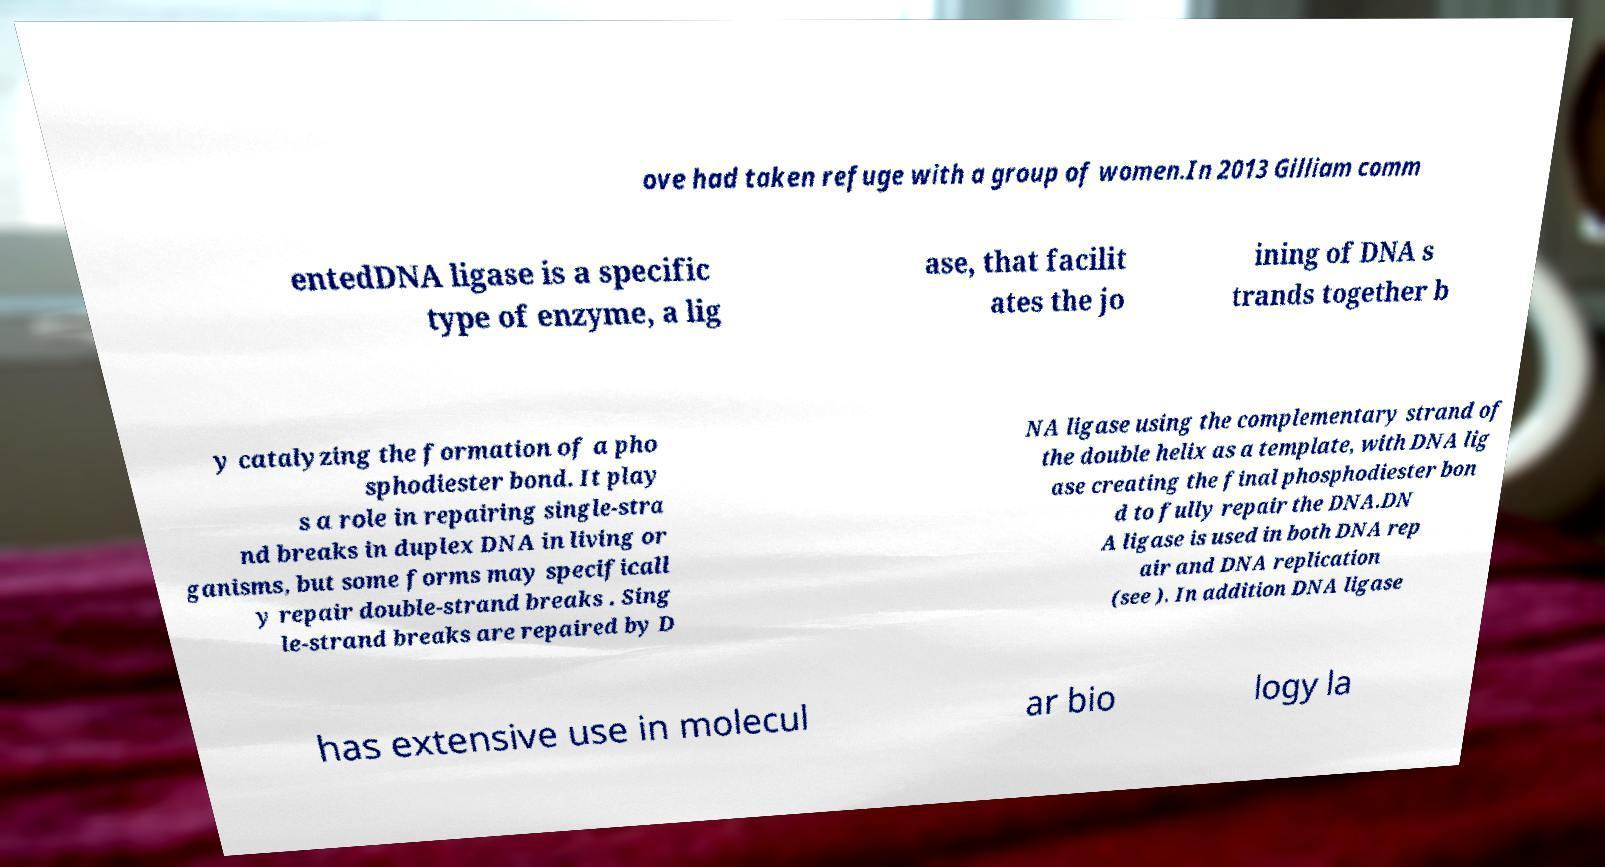There's text embedded in this image that I need extracted. Can you transcribe it verbatim? ove had taken refuge with a group of women.In 2013 Gilliam comm entedDNA ligase is a specific type of enzyme, a lig ase, that facilit ates the jo ining of DNA s trands together b y catalyzing the formation of a pho sphodiester bond. It play s a role in repairing single-stra nd breaks in duplex DNA in living or ganisms, but some forms may specificall y repair double-strand breaks . Sing le-strand breaks are repaired by D NA ligase using the complementary strand of the double helix as a template, with DNA lig ase creating the final phosphodiester bon d to fully repair the DNA.DN A ligase is used in both DNA rep air and DNA replication (see ). In addition DNA ligase has extensive use in molecul ar bio logy la 